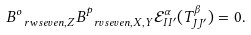<formula> <loc_0><loc_0><loc_500><loc_500>B ^ { o } _ { \ r w s e v e n , Z } B ^ { p } _ { \ r v s e v e n , X , Y } \mathcal { E } ^ { \alpha } _ { I I ^ { \prime } } ( T ^ { \beta } _ { J J ^ { \prime } } ) = 0 .</formula> 